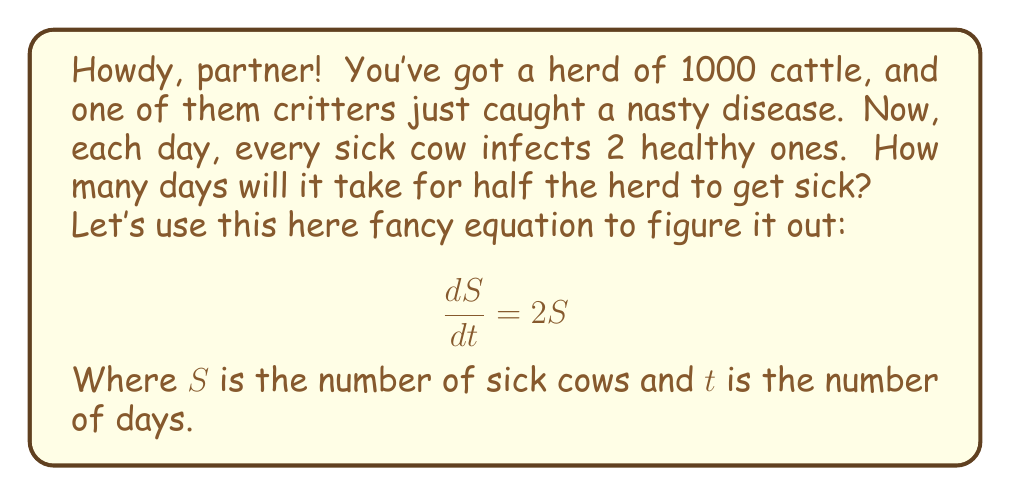Give your solution to this math problem. Alright, let's break this down like we're splittin' firewood:

1) We start with 1 sick cow, so $S_0 = 1$.

2) We need to find when $S = 500$ (half the herd).

3) The solution to our fancy equation is:

   $$S = S_0 e^{2t}$$

4) Pluggin' in what we know:

   $$500 = 1 \cdot e^{2t}$$

5) Now, let's wrangle this equation:

   $$500 = e^{2t}$$
   $$\ln(500) = 2t$$
   $$t = \frac{\ln(500)}{2}$$

6) Use a calculator (or count on your fingers real fast) to get:

   $$t \approx 3.11$$

7) Since we can't have a fraction of a day, we round up to the next whole day.
Answer: It'll take 4 days for half the herd to get sick. 